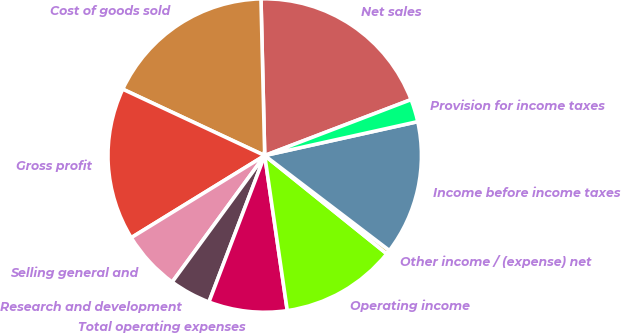Convert chart. <chart><loc_0><loc_0><loc_500><loc_500><pie_chart><fcel>Net sales<fcel>Cost of goods sold<fcel>Gross profit<fcel>Selling general and<fcel>Research and development<fcel>Total operating expenses<fcel>Operating income<fcel>Other income / (expense) net<fcel>Income before income taxes<fcel>Provision for income taxes<nl><fcel>19.57%<fcel>17.66%<fcel>15.74%<fcel>6.17%<fcel>4.26%<fcel>8.09%<fcel>11.91%<fcel>0.43%<fcel>13.83%<fcel>2.34%<nl></chart> 